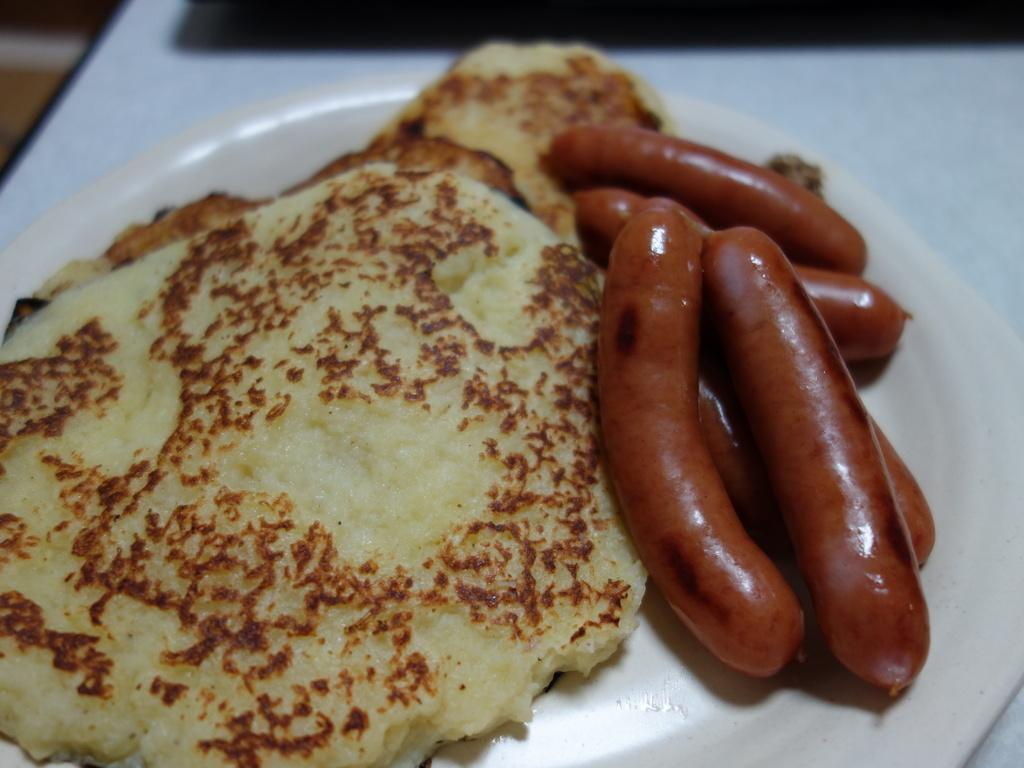What object is present on the table in the image? There is a plate in the image. What is on the plate that is visible in the image? The plate contains pancakes and sausages. What type of work is the bee doing in the image? There is no bee present in the image, so it cannot be determined what type of work it might be doing. 